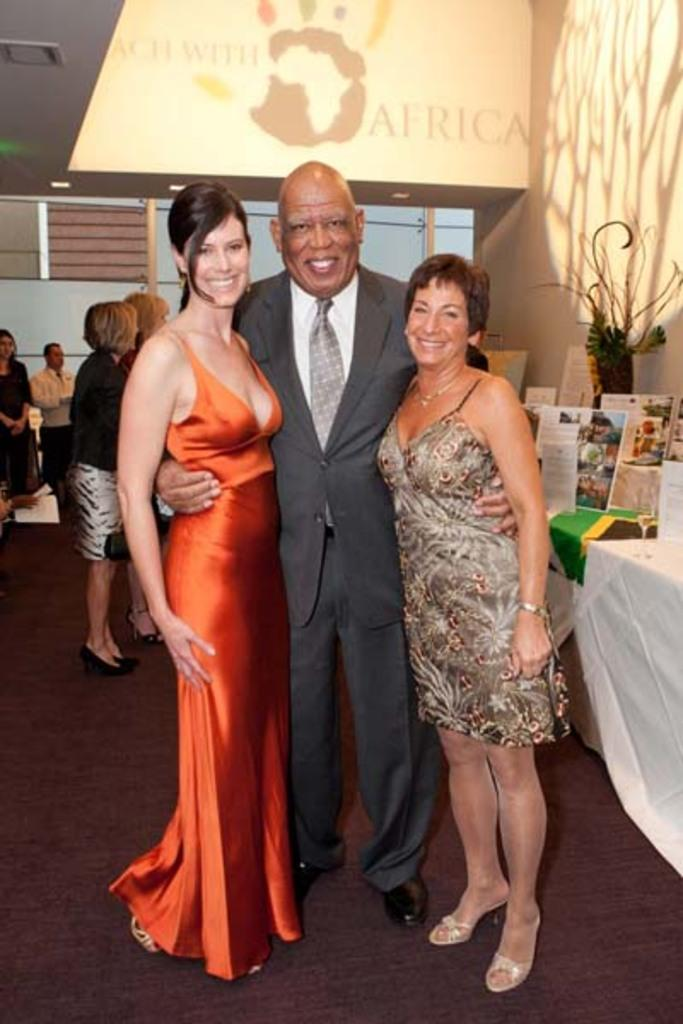What is the main subject of the image? The main subject of the image is a man. What is the man doing in the image? The man is standing with his hands on two girls. Can you describe the girl in the image? There is a beautiful girl in the image, and she is wearing an orange color dress. What is the girl's expression in the image? The girl is smiling in the image. What type of pen is the man using to write on the clock in the image? There is no pen or clock present in the image; it features a man standing with his hands on two girls. 